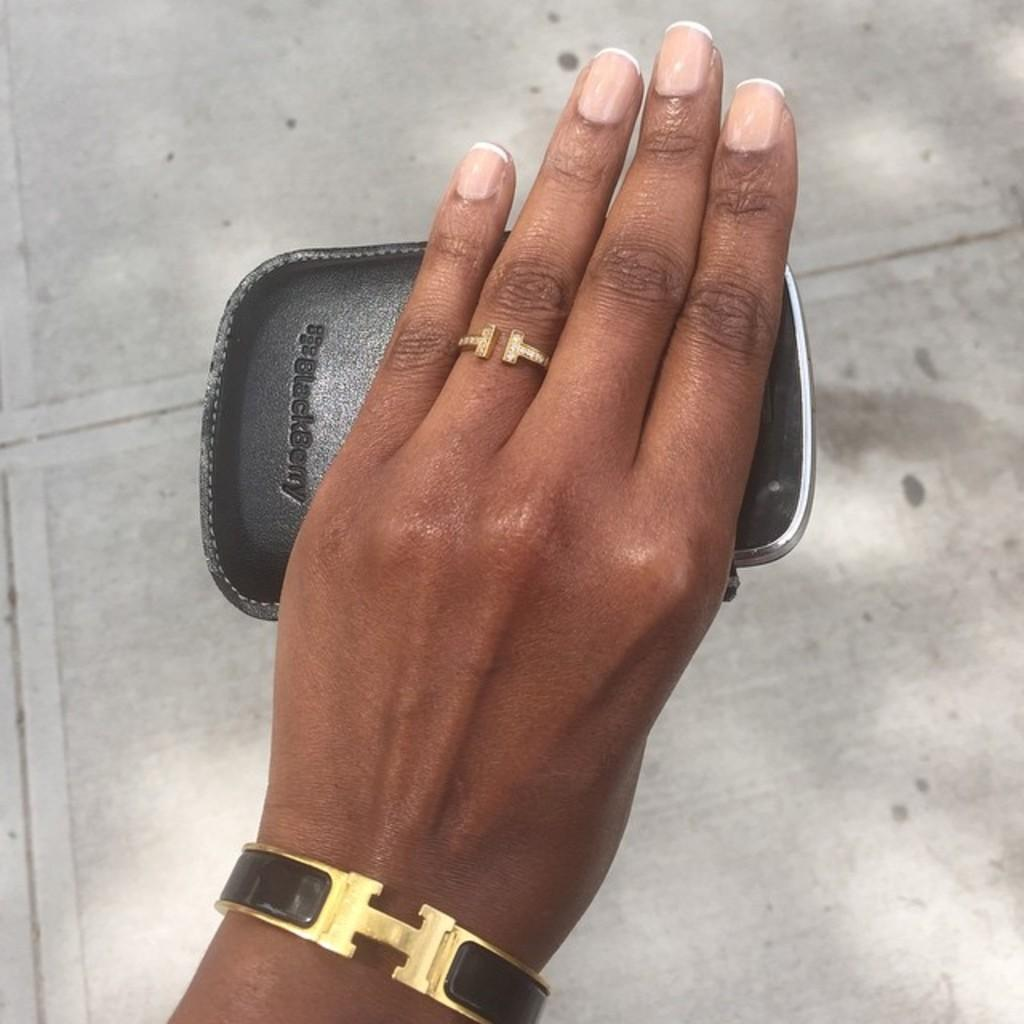<image>
Give a short and clear explanation of the subsequent image. A womans hand holding a case with the word blackberry printed on it 